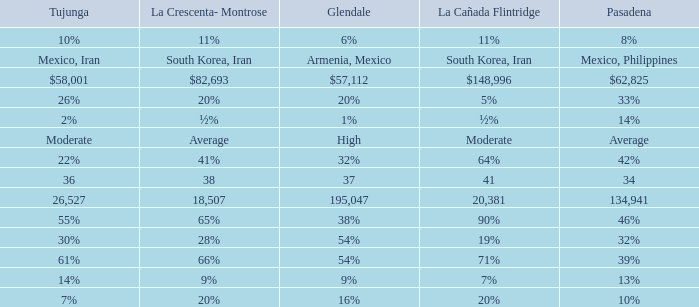When Pasadena is at 10%, what is La Crescenta-Montrose? 20%. 